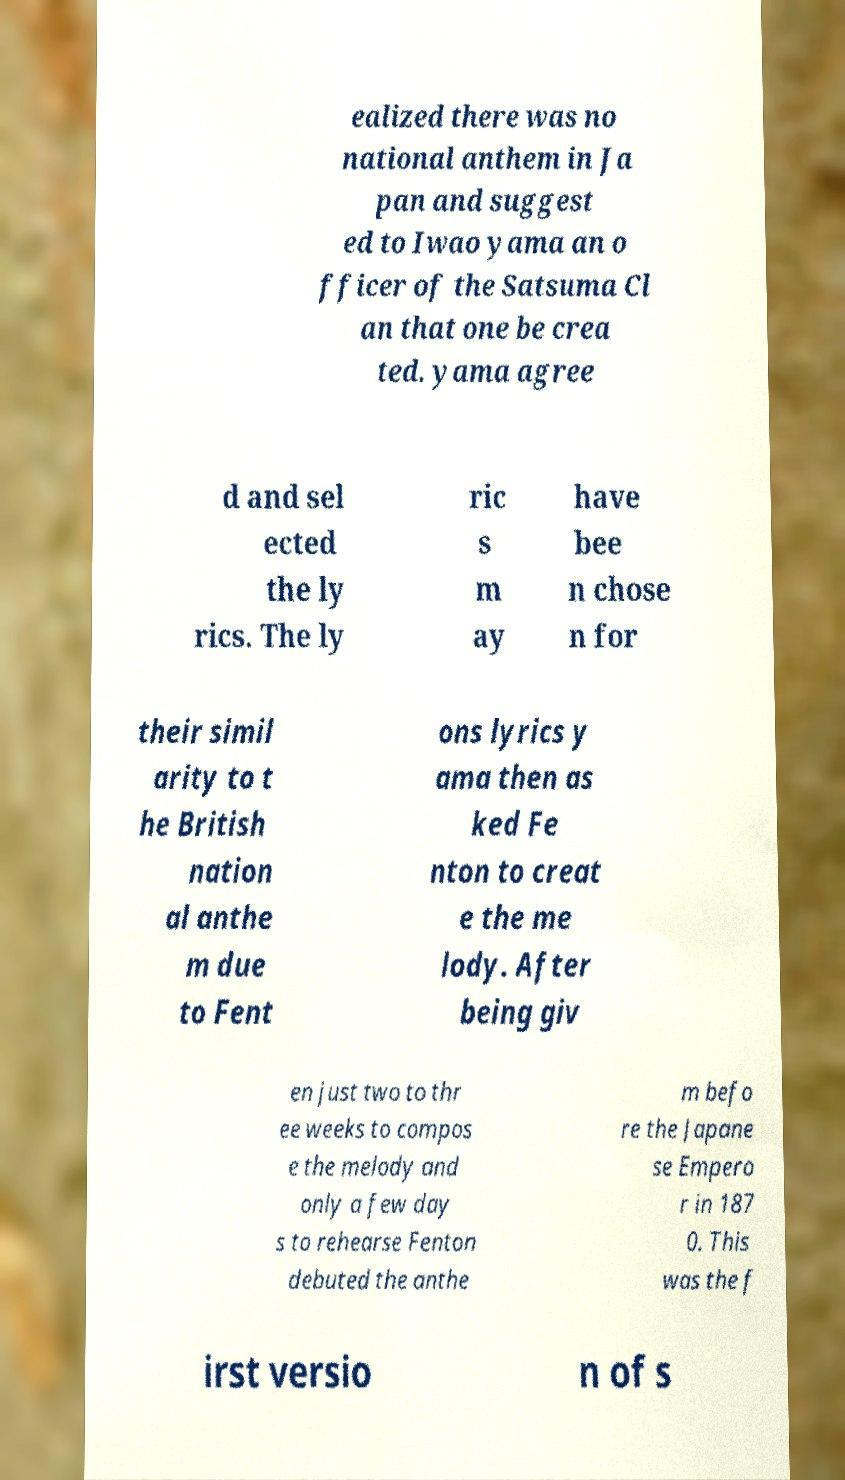Could you assist in decoding the text presented in this image and type it out clearly? ealized there was no national anthem in Ja pan and suggest ed to Iwao yama an o fficer of the Satsuma Cl an that one be crea ted. yama agree d and sel ected the ly rics. The ly ric s m ay have bee n chose n for their simil arity to t he British nation al anthe m due to Fent ons lyrics y ama then as ked Fe nton to creat e the me lody. After being giv en just two to thr ee weeks to compos e the melody and only a few day s to rehearse Fenton debuted the anthe m befo re the Japane se Empero r in 187 0. This was the f irst versio n of s 